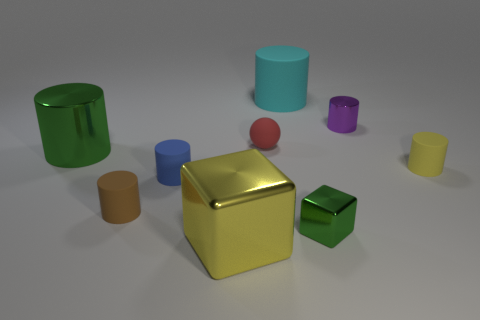Subtract 1 cylinders. How many cylinders are left? 5 Subtract all big green cylinders. How many cylinders are left? 5 Subtract all purple cylinders. How many cylinders are left? 5 Subtract all cyan cylinders. Subtract all purple balls. How many cylinders are left? 5 Subtract all balls. How many objects are left? 8 Add 6 tiny blue blocks. How many tiny blue blocks exist? 6 Subtract 0 red blocks. How many objects are left? 9 Subtract all large cyan rubber things. Subtract all large metal blocks. How many objects are left? 7 Add 4 cylinders. How many cylinders are left? 10 